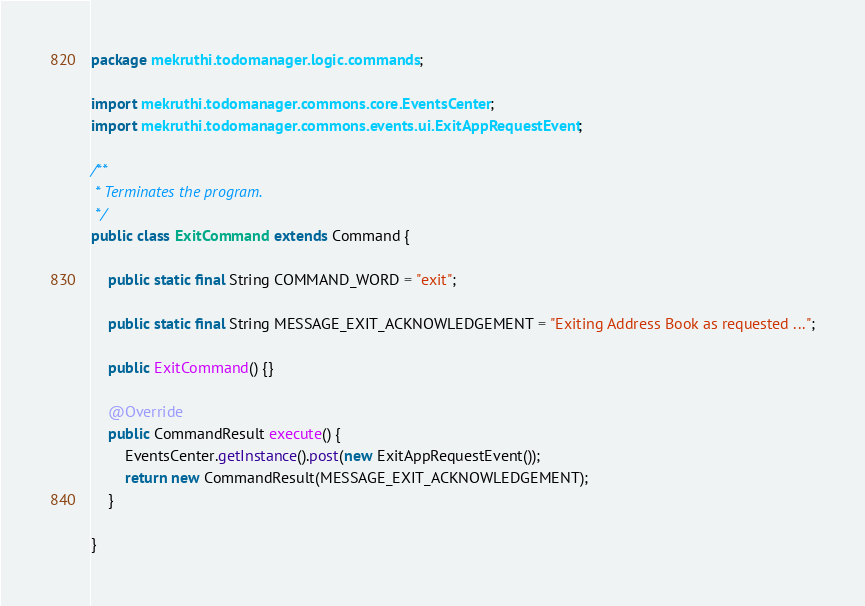Convert code to text. <code><loc_0><loc_0><loc_500><loc_500><_Java_>package mekruthi.todomanager.logic.commands;

import mekruthi.todomanager.commons.core.EventsCenter;
import mekruthi.todomanager.commons.events.ui.ExitAppRequestEvent;

/**
 * Terminates the program.
 */
public class ExitCommand extends Command {

    public static final String COMMAND_WORD = "exit";

    public static final String MESSAGE_EXIT_ACKNOWLEDGEMENT = "Exiting Address Book as requested ...";

    public ExitCommand() {}

    @Override
    public CommandResult execute() {
        EventsCenter.getInstance().post(new ExitAppRequestEvent());
        return new CommandResult(MESSAGE_EXIT_ACKNOWLEDGEMENT);
    }

}
</code> 